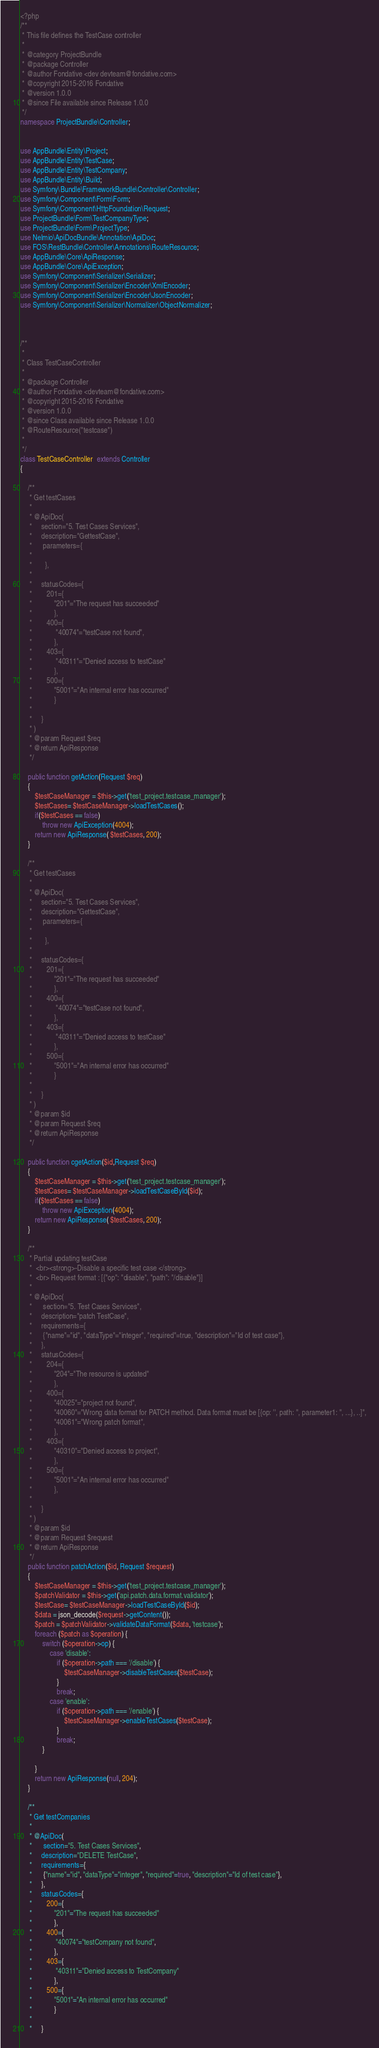Convert code to text. <code><loc_0><loc_0><loc_500><loc_500><_PHP_><?php
/**
 * This file defines the TestCase controller
 *
 * @category ProjectBundle
 * @package Controller
 * @author Fondative <dev devteam@fondative.com>
 * @copyright 2015-2016 Fondative
 * @version 1.0.0
 * @since File available since Release 1.0.0
 */
namespace ProjectBundle\Controller;


use AppBundle\Entity\Project;
use AppBundle\Entity\TestCase;
use AppBundle\Entity\TestCompany;
use AppBundle\Entity\Build;
use Symfony\Bundle\FrameworkBundle\Controller\Controller;
use Symfony\Component\Form\Form;
use Symfony\Component\HttpFoundation\Request;
use ProjectBundle\Form\TestCompanyType;
use ProjectBundle\Form\ProjectType;
use Nelmio\ApiDocBundle\Annotation\ApiDoc;
use FOS\RestBundle\Controller\Annotations\RouteResource;
use AppBundle\Core\ApiResponse;
use AppBundle\Core\ApiException;
use Symfony\Component\Serializer\Serializer;
use Symfony\Component\Serializer\Encoder\XmlEncoder;
use Symfony\Component\Serializer\Encoder\JsonEncoder;
use Symfony\Component\Serializer\Normalizer\ObjectNormalizer;



/**
 *
 * Class TestCaseController
 *
 * @package Controller
 * @author Fondative <devteam@fondative.com>
 * @copyright 2015-2016 Fondative
 * @version 1.0.0
 * @since Class available since Release 1.0.0
 * @RouteResource("testcase")
 *
 */
class TestCaseController  extends Controller
{

    /**
     * Get testCases
     *
     * @ApiDoc(
     *     section="5. Test Cases Services",
     *     description="GettestCase",
     *      parameters={
     *
     *       },
     *
     *     statusCodes={
     *        201={
     *            "201"="The request has succeeded"
     *            },
     *        400={
     *             "40074"="testCase not found",
     *            },
     *        403={
     *             "40311"="Denied access to testCase"
     *            },
     *        500={
     *            "5001"="An internal error has occurred"
     *            }
     *
     *     }
     * )
     * @param Request $req
     * @return ApiResponse
     */

    public function getAction(Request $req)
    {
        $testCaseManager = $this->get('test_project.testcase_manager');
        $testCases= $testCaseManager->loadTestCases();
        if($testCases == false)
            throw new ApiException(4004);
        return new ApiResponse( $testCases, 200);
    }

    /**
     * Get testCases
     *
     * @ApiDoc(
     *     section="5. Test Cases Services",
     *     description="GettestCase",
     *      parameters={
     *
     *       },
     *
     *     statusCodes={
     *        201={
     *            "201"="The request has succeeded"
     *            },
     *        400={
     *             "40074"="testCase not found",
     *            },
     *        403={
     *             "40311"="Denied access to testCase"
     *            },
     *        500={
     *            "5001"="An internal error has occurred"
     *            }
     *
     *     }
     * )
     * @param $id
     * @param Request $req
     * @return ApiResponse
     */

    public function cgetAction($id,Request $req)
    {
        $testCaseManager = $this->get('test_project.testcase_manager');
        $testCases= $testCaseManager->loadTestCaseById($id);
        if($testCases == false)
            throw new ApiException(4004);
        return new ApiResponse( $testCases, 200);
    }

    /**
     * Partial updating testCase
     *  <br><strong>-Disable a specific test case </strong>
     *  <br> Request format : [{"op": "disable", "path": "/disable"}]
     *
     * @ApiDoc(
     *      section="5. Test Cases Services",
     *     description="patch TestCase",
     *     requirements={
     *      {"name"="id", "dataType"="integer", "required"=true, "description"="Id of test case"},
     *     },
     *     statusCodes={
     *        204={
     *            "204"="The resource is updated"
     *            },
     *        400={
     *            "40025"="project not found",
     *            "40060"="Wrong data format for PATCH method. Data format must be [{op: '', path: '', parameter1: '', ...}, ..]",
     *            "40061"="Wrong patch format",
     *            },
     *        403={
     *            "40310"="Denied access to project",
     *            },
     *        500={
     *            "5001"="An internal error has occurred"
     *            },
     *
     *     }
     * )
     * @param $id
     * @param Request $request
     * @return ApiResponse
     */
    public function patchAction($id, Request $request)
    {
        $testCaseManager = $this->get('test_project.testcase_manager');
        $patchValidator = $this->get('api.patch.data.format.validator');
        $testCase= $testCaseManager->loadTestCaseById($id);
        $data = json_decode($request->getContent());
        $patch = $patchValidator->validateDataFormat($data, 'testcase');
        foreach ($patch as $operation) {
            switch ($operation->op) {
                case 'disable':
                    if ($operation->path === '/disable') {
                        $testCaseManager->disableTestCases($testCase);
                    }
                    break;
                case 'enable':
                    if ($operation->path === '/enable') {
                        $testCaseManager->enableTestCases($testCase);
                    }
                    break;
            }

        }
        return new ApiResponse(null, 204);
    }

    /**
     * Get testCompanies
     *
     * @ApiDoc(
     *      section="5. Test Cases Services",
     *     description="DELETE TestCase",
     *     requirements={
     *      {"name"="id", "dataType"="integer", "required"=true, "description"="Id of test case"},
     *     },
     *     statusCodes={
     *        200={
     *            "201"="The request has succeeded"
     *            },
     *        400={
     *             "40074"="testCompany not found",
     *            },
     *        403={
     *             "40311"="Denied access to TestCompany"
     *            },
     *        500={
     *            "5001"="An internal error has occurred"
     *            }
     *
     *     }</code> 